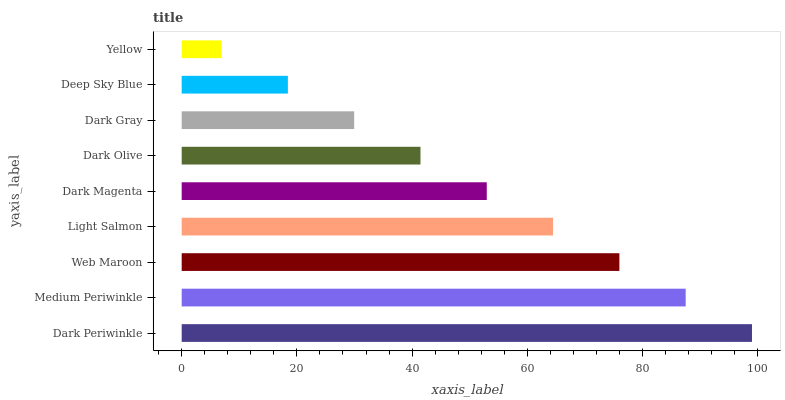Is Yellow the minimum?
Answer yes or no. Yes. Is Dark Periwinkle the maximum?
Answer yes or no. Yes. Is Medium Periwinkle the minimum?
Answer yes or no. No. Is Medium Periwinkle the maximum?
Answer yes or no. No. Is Dark Periwinkle greater than Medium Periwinkle?
Answer yes or no. Yes. Is Medium Periwinkle less than Dark Periwinkle?
Answer yes or no. Yes. Is Medium Periwinkle greater than Dark Periwinkle?
Answer yes or no. No. Is Dark Periwinkle less than Medium Periwinkle?
Answer yes or no. No. Is Dark Magenta the high median?
Answer yes or no. Yes. Is Dark Magenta the low median?
Answer yes or no. Yes. Is Deep Sky Blue the high median?
Answer yes or no. No. Is Web Maroon the low median?
Answer yes or no. No. 